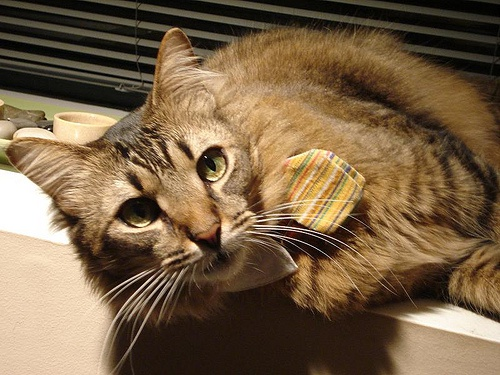Describe the objects in this image and their specific colors. I can see cat in black, maroon, and tan tones, tie in black, tan, and gold tones, and cup in black, tan, and lightyellow tones in this image. 